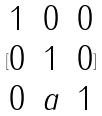<formula> <loc_0><loc_0><loc_500><loc_500>[ \begin{matrix} 1 & 0 & 0 \\ 0 & 1 & 0 \\ 0 & a & 1 \end{matrix} ]</formula> 